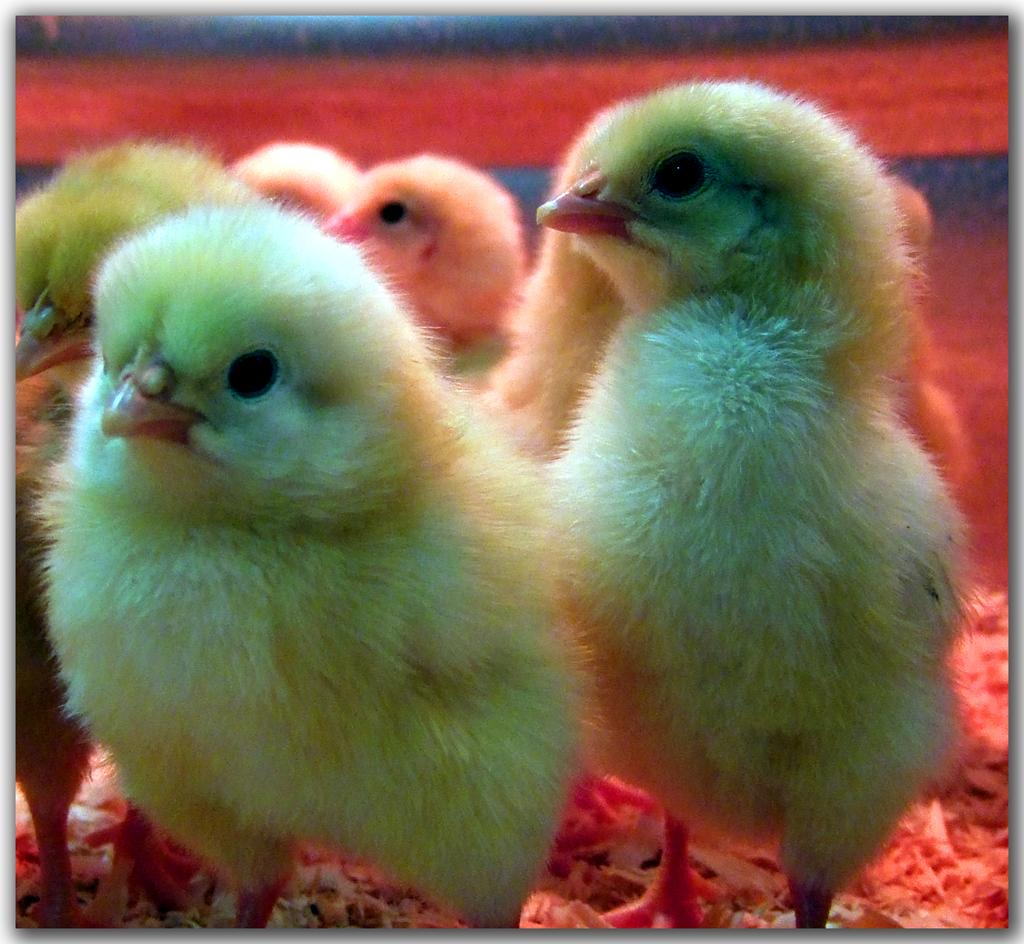What type of animals are in the image? There are beautiful yellow color chicks in the image. What position are the chicks in? The chicks are standing. What type of fruit can be seen in the image? There are no fruits present in the image; it features beautiful yellow color chicks. What type of ocean can be seen in the background of the image? There is no ocean present in the image; it features chicks standing on a surface. 